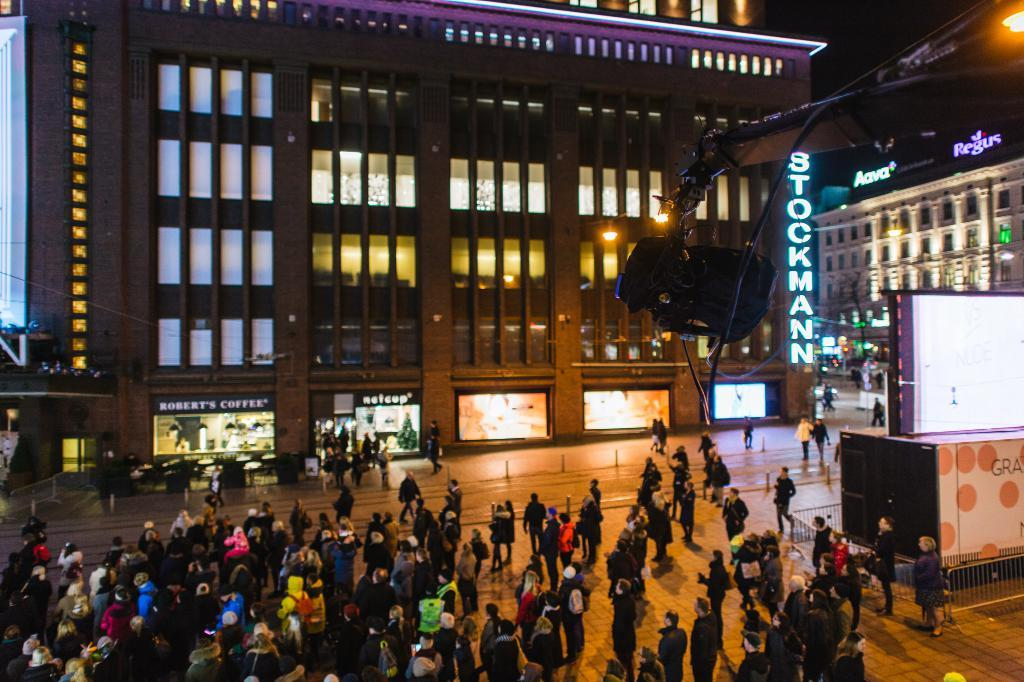<image>
Render a clear and concise summary of the photo. A crowd of people are in front of a building that says Stockmann at night. 